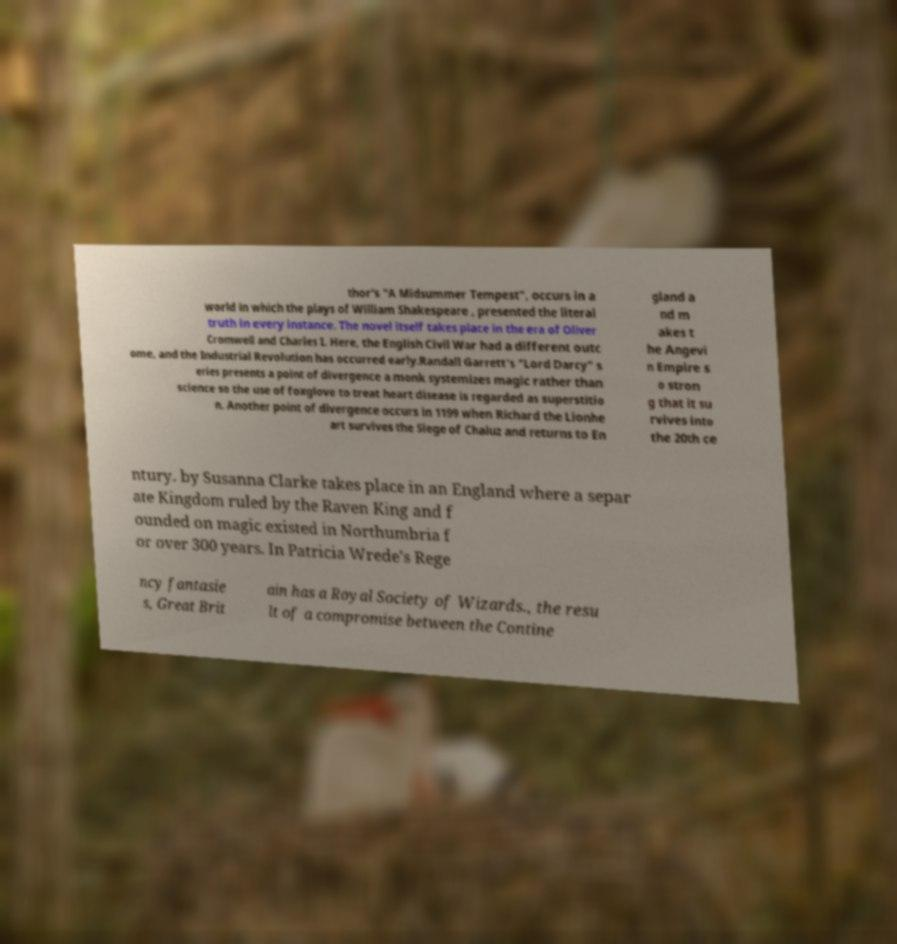Please identify and transcribe the text found in this image. thor's "A Midsummer Tempest", occurs in a world in which the plays of William Shakespeare , presented the literal truth in every instance. The novel itself takes place in the era of Oliver Cromwell and Charles I. Here, the English Civil War had a different outc ome, and the Industrial Revolution has occurred early.Randall Garrett's "Lord Darcy" s eries presents a point of divergence a monk systemizes magic rather than science so the use of foxglove to treat heart disease is regarded as superstitio n. Another point of divergence occurs in 1199 when Richard the Lionhe art survives the Siege of Chaluz and returns to En gland a nd m akes t he Angevi n Empire s o stron g that it su rvives into the 20th ce ntury. by Susanna Clarke takes place in an England where a separ ate Kingdom ruled by the Raven King and f ounded on magic existed in Northumbria f or over 300 years. In Patricia Wrede's Rege ncy fantasie s, Great Brit ain has a Royal Society of Wizards., the resu lt of a compromise between the Contine 